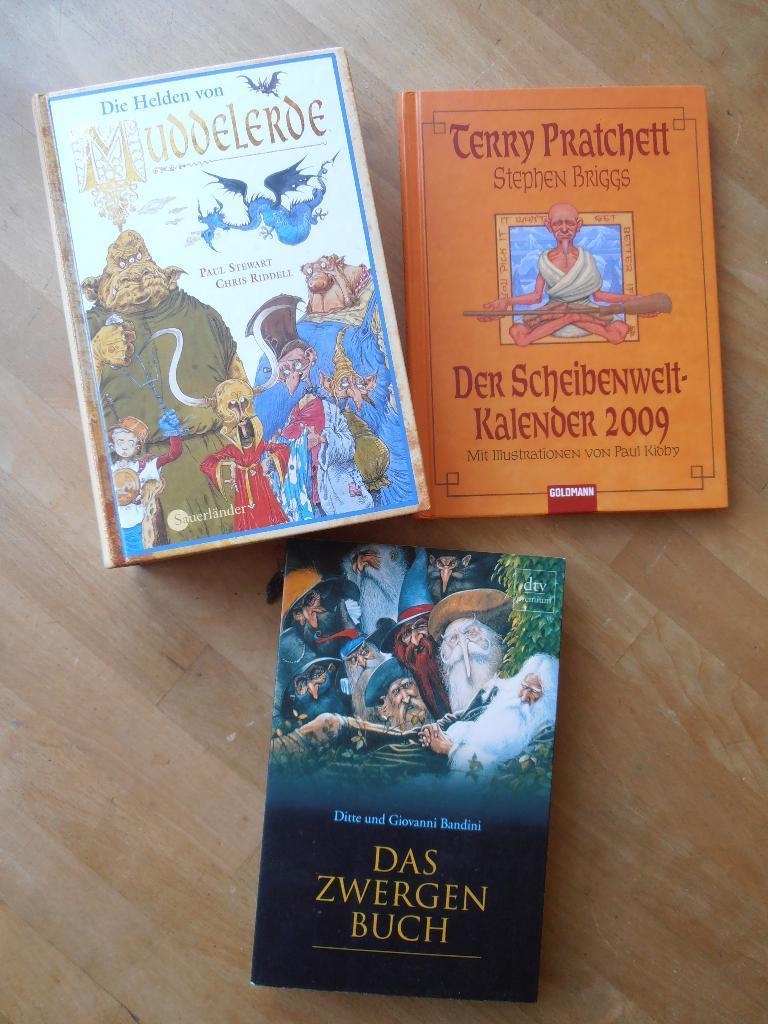Provide a one-sentence caption for the provided image. Three foreign children's books are sitting on a table. 